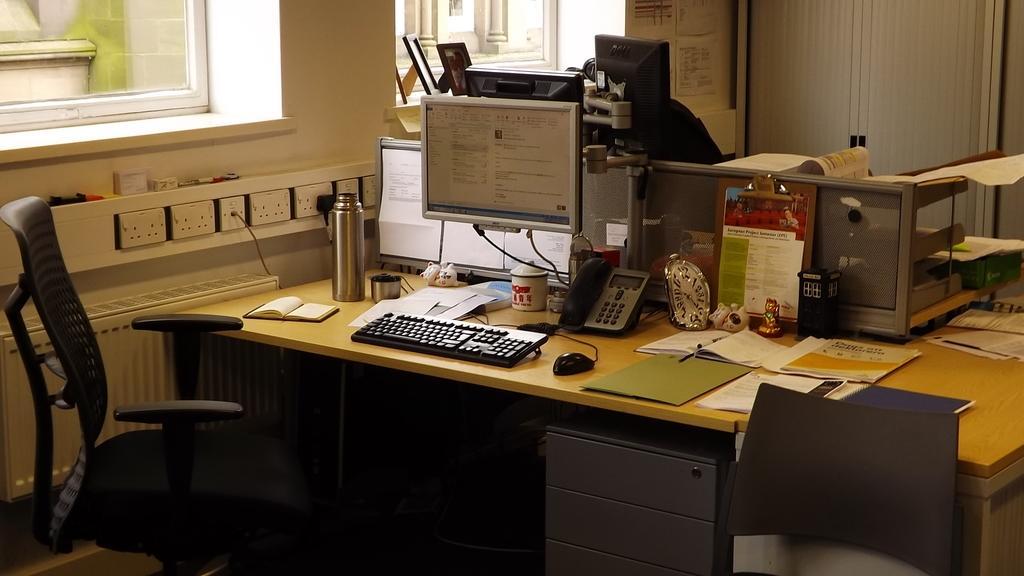How would you summarize this image in a sentence or two? in this image one room is there inside the many things are there on the table like phone,laptop,keyboard,thermos flask and book,watch and some books are there and something is there inside the room and chairs are also there inside the room. 